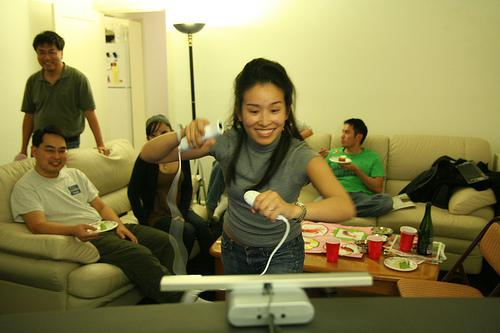Question: who is playing the video game?
Choices:
A. A toddler.
B. A girl.
C. A teen.
D. A child.
Answer with the letter. Answer: B Question: why is the girl standing in the middle?
Choices:
A. Trying new shoes.
B. Posing for a photo.
C. Playing video game.
D. Looking for her doll.
Answer with the letter. Answer: C Question: what color is the shirt of the girl in the middle?
Choices:
A. White.
B. Pink.
C. Blue.
D. Gray.
Answer with the letter. Answer: D Question: what color are the couches?
Choices:
A. White.
B. Black.
C. Tan.
D. Red.
Answer with the letter. Answer: C 